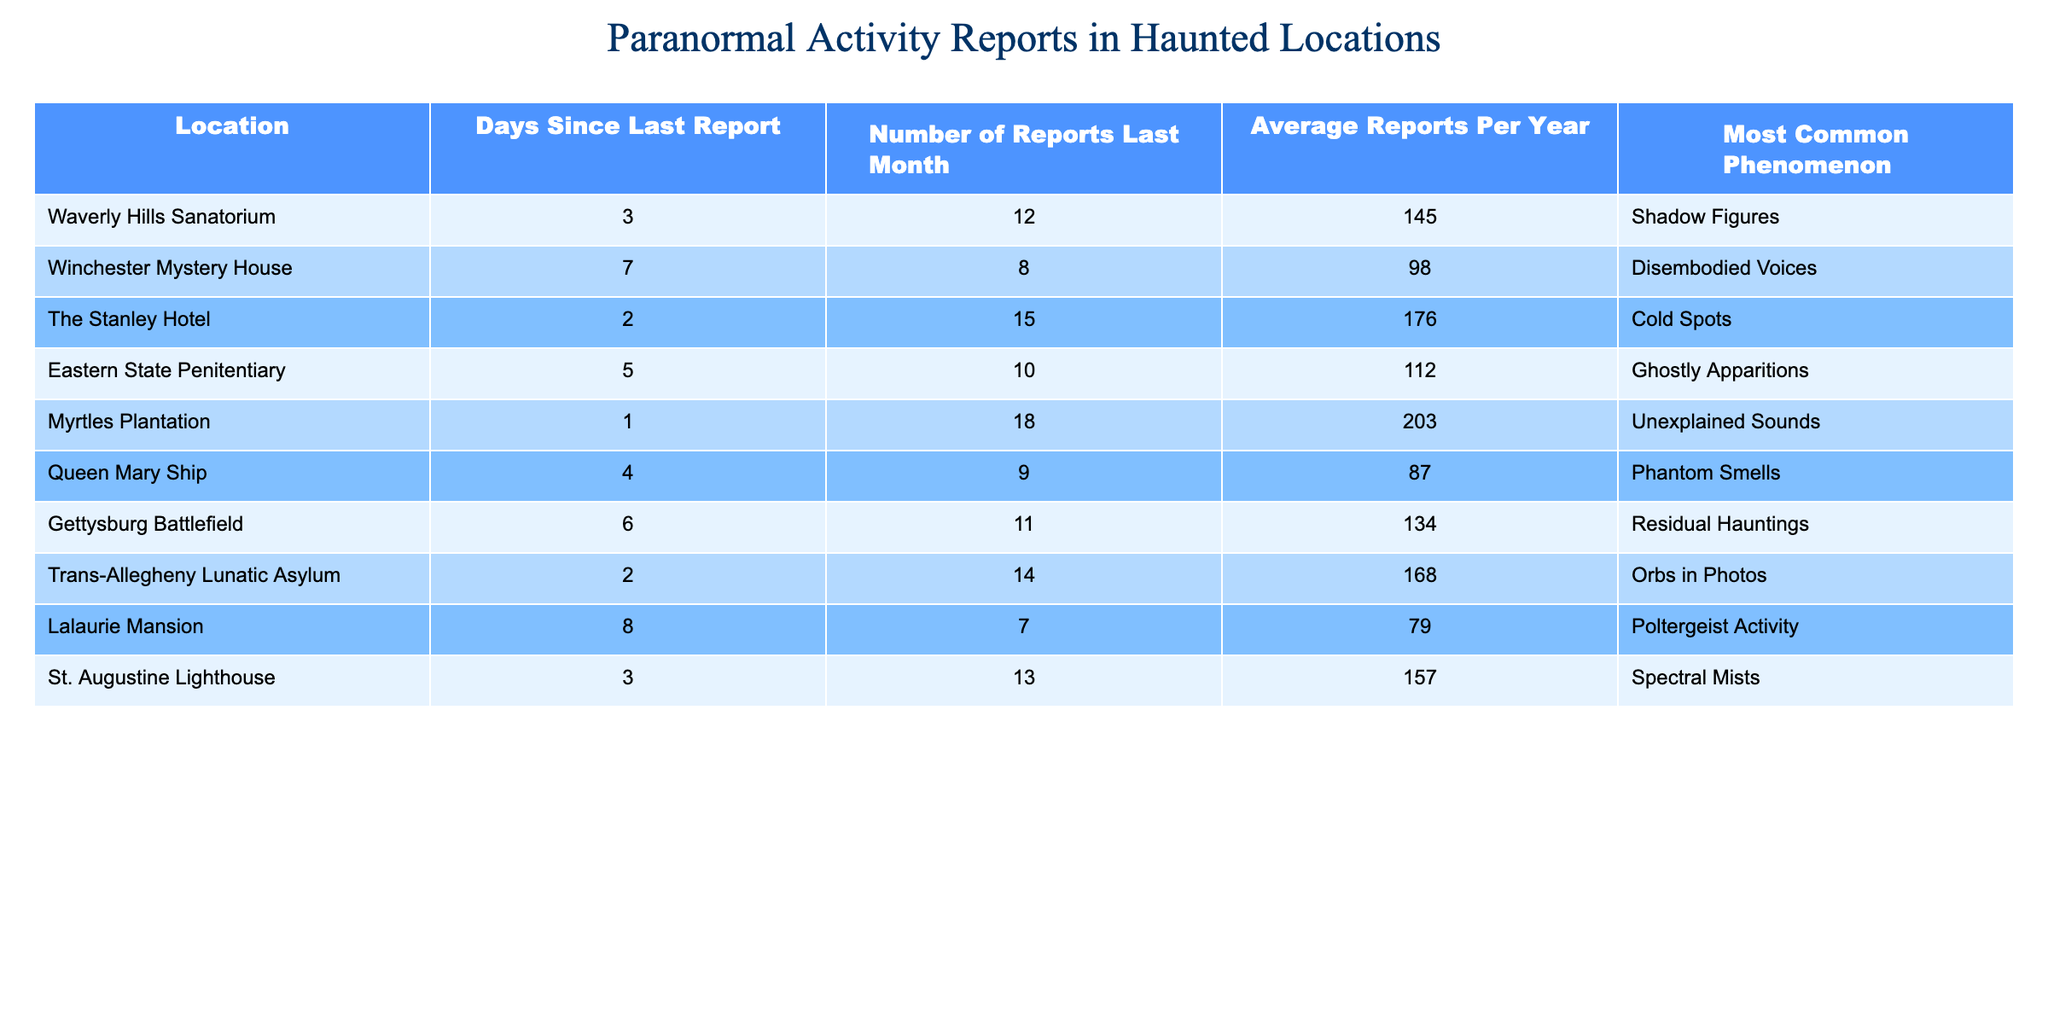What is the most common phenomenon reported at Waverly Hills Sanatorium? The table shows that the most common phenomenon reported at Waverly Hills Sanatorium is "Shadow Figures."
Answer: Shadow Figures Which haunted location has the highest number of reports last month? Looking at the "Number of Reports Last Month" column, Myrtles Plantation has the highest number of reports at 18.
Answer: Myrtles Plantation How many reports were made at The Stanley Hotel last month? According to the table, The Stanley Hotel had 15 reports made last month.
Answer: 15 What is the average number of reports per year at Eastern State Penitentiary? The table indicates that Eastern State Penitentiary has an average of 112 reports per year.
Answer: 112 At which location was the least number of reports made last month, and what was that number? By examining the "Number of Reports Last Month" column, Lalaurie Mansion has the least at 7 reports.
Answer: 7 What is the total number of reports for the locations with "Ghostly Apparitions" as the most common phenomenon? The only location listed with "Ghostly Apparitions" is Eastern State Penitentiary, which has 10 reports last month. Therefore, the total is 10.
Answer: 10 Which haunted location has reported more average reports per year, Queen Mary Ship or Lalaurie Mansion? The average reports per year for Queen Mary Ship is 87, while Lalaurie Mansion has 79. Since 87 is greater than 79, Queen Mary Ship has more reports.
Answer: Queen Mary Ship What is the sum of days since the last report for the locations that have 10 or more reports last month? The locations with 10 or more reports last month are Waverly Hills Sanatorium (3), The Stanley Hotel (2), Myrtles Plantation (1), Eastern State Penitentiary (5), Trans-Allegheny Lunatic Asylum (2), and St. Augustine Lighthouse (3). Adding those values gives 3 + 2 + 1 + 5 + 2 + 3 = 16.
Answer: 16 Is it true that the Winchester Mystery House has a higher average number of reports per year than the Queen Mary Ship? The average for Winchester Mystery House is 98, whereas Queen Mary Ship has 87. Since 98 is greater than 87, this statement is true.
Answer: True Which location has the fewest days since the last report, and what is that number? By reviewing the "Days Since Last Report" column, Myrtles Plantation has the fewest days with just 1 day since the last report.
Answer: 1 